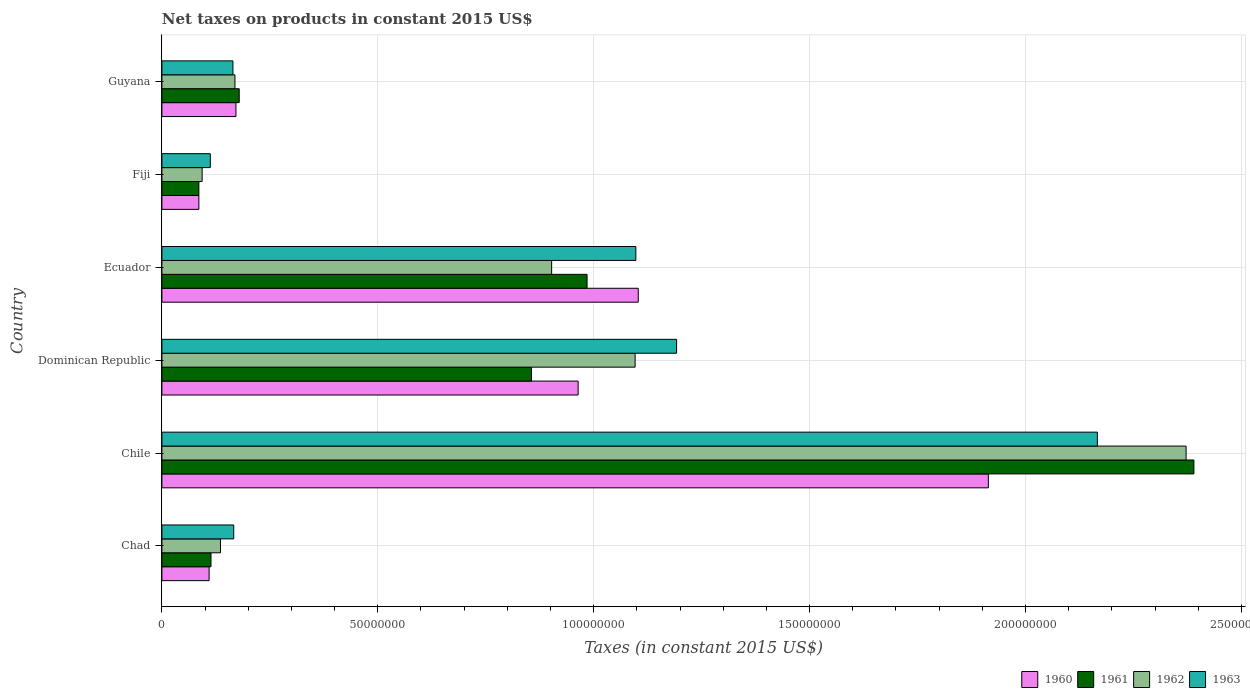How many different coloured bars are there?
Make the answer very short. 4. Are the number of bars per tick equal to the number of legend labels?
Provide a short and direct response. Yes. How many bars are there on the 5th tick from the top?
Your answer should be compact. 4. How many bars are there on the 5th tick from the bottom?
Keep it short and to the point. 4. What is the label of the 4th group of bars from the top?
Your response must be concise. Dominican Republic. In how many cases, is the number of bars for a given country not equal to the number of legend labels?
Make the answer very short. 0. What is the net taxes on products in 1962 in Chad?
Offer a terse response. 1.36e+07. Across all countries, what is the maximum net taxes on products in 1963?
Offer a very short reply. 2.17e+08. Across all countries, what is the minimum net taxes on products in 1962?
Your response must be concise. 9.32e+06. In which country was the net taxes on products in 1960 maximum?
Provide a succinct answer. Chile. In which country was the net taxes on products in 1962 minimum?
Ensure brevity in your answer.  Fiji. What is the total net taxes on products in 1962 in the graph?
Keep it short and to the point. 4.77e+08. What is the difference between the net taxes on products in 1961 in Ecuador and that in Fiji?
Offer a terse response. 8.99e+07. What is the difference between the net taxes on products in 1962 in Dominican Republic and the net taxes on products in 1963 in Fiji?
Offer a terse response. 9.84e+07. What is the average net taxes on products in 1960 per country?
Ensure brevity in your answer.  7.25e+07. What is the difference between the net taxes on products in 1963 and net taxes on products in 1960 in Fiji?
Keep it short and to the point. 2.64e+06. In how many countries, is the net taxes on products in 1961 greater than 40000000 US$?
Keep it short and to the point. 3. What is the ratio of the net taxes on products in 1960 in Dominican Republic to that in Fiji?
Your answer should be compact. 11.26. Is the difference between the net taxes on products in 1963 in Chad and Guyana greater than the difference between the net taxes on products in 1960 in Chad and Guyana?
Provide a short and direct response. Yes. What is the difference between the highest and the second highest net taxes on products in 1961?
Ensure brevity in your answer.  1.41e+08. What is the difference between the highest and the lowest net taxes on products in 1962?
Your answer should be compact. 2.28e+08. Is the sum of the net taxes on products in 1962 in Chile and Ecuador greater than the maximum net taxes on products in 1963 across all countries?
Keep it short and to the point. Yes. Is it the case that in every country, the sum of the net taxes on products in 1961 and net taxes on products in 1960 is greater than the sum of net taxes on products in 1963 and net taxes on products in 1962?
Ensure brevity in your answer.  No. What does the 1st bar from the top in Chile represents?
Your answer should be very brief. 1963. What does the 4th bar from the bottom in Dominican Republic represents?
Ensure brevity in your answer.  1963. Is it the case that in every country, the sum of the net taxes on products in 1961 and net taxes on products in 1962 is greater than the net taxes on products in 1960?
Make the answer very short. Yes. How many bars are there?
Offer a terse response. 24. Are all the bars in the graph horizontal?
Your answer should be very brief. Yes. How many countries are there in the graph?
Give a very brief answer. 6. What is the difference between two consecutive major ticks on the X-axis?
Your answer should be very brief. 5.00e+07. Does the graph contain grids?
Keep it short and to the point. Yes. How many legend labels are there?
Ensure brevity in your answer.  4. How are the legend labels stacked?
Your answer should be very brief. Horizontal. What is the title of the graph?
Keep it short and to the point. Net taxes on products in constant 2015 US$. What is the label or title of the X-axis?
Your answer should be compact. Taxes (in constant 2015 US$). What is the Taxes (in constant 2015 US$) in 1960 in Chad?
Your answer should be compact. 1.09e+07. What is the Taxes (in constant 2015 US$) of 1961 in Chad?
Ensure brevity in your answer.  1.14e+07. What is the Taxes (in constant 2015 US$) of 1962 in Chad?
Your response must be concise. 1.36e+07. What is the Taxes (in constant 2015 US$) of 1963 in Chad?
Offer a terse response. 1.66e+07. What is the Taxes (in constant 2015 US$) in 1960 in Chile?
Your answer should be compact. 1.91e+08. What is the Taxes (in constant 2015 US$) in 1961 in Chile?
Offer a terse response. 2.39e+08. What is the Taxes (in constant 2015 US$) in 1962 in Chile?
Ensure brevity in your answer.  2.37e+08. What is the Taxes (in constant 2015 US$) in 1963 in Chile?
Provide a succinct answer. 2.17e+08. What is the Taxes (in constant 2015 US$) in 1960 in Dominican Republic?
Keep it short and to the point. 9.64e+07. What is the Taxes (in constant 2015 US$) of 1961 in Dominican Republic?
Offer a terse response. 8.56e+07. What is the Taxes (in constant 2015 US$) in 1962 in Dominican Republic?
Give a very brief answer. 1.10e+08. What is the Taxes (in constant 2015 US$) in 1963 in Dominican Republic?
Your answer should be compact. 1.19e+08. What is the Taxes (in constant 2015 US$) in 1960 in Ecuador?
Your answer should be compact. 1.10e+08. What is the Taxes (in constant 2015 US$) in 1961 in Ecuador?
Provide a succinct answer. 9.85e+07. What is the Taxes (in constant 2015 US$) of 1962 in Ecuador?
Ensure brevity in your answer.  9.03e+07. What is the Taxes (in constant 2015 US$) of 1963 in Ecuador?
Offer a terse response. 1.10e+08. What is the Taxes (in constant 2015 US$) of 1960 in Fiji?
Make the answer very short. 8.56e+06. What is the Taxes (in constant 2015 US$) of 1961 in Fiji?
Your answer should be very brief. 8.56e+06. What is the Taxes (in constant 2015 US$) in 1962 in Fiji?
Make the answer very short. 9.32e+06. What is the Taxes (in constant 2015 US$) of 1963 in Fiji?
Offer a very short reply. 1.12e+07. What is the Taxes (in constant 2015 US$) of 1960 in Guyana?
Give a very brief answer. 1.71e+07. What is the Taxes (in constant 2015 US$) in 1961 in Guyana?
Give a very brief answer. 1.79e+07. What is the Taxes (in constant 2015 US$) in 1962 in Guyana?
Offer a terse response. 1.69e+07. What is the Taxes (in constant 2015 US$) in 1963 in Guyana?
Make the answer very short. 1.64e+07. Across all countries, what is the maximum Taxes (in constant 2015 US$) of 1960?
Make the answer very short. 1.91e+08. Across all countries, what is the maximum Taxes (in constant 2015 US$) of 1961?
Your answer should be very brief. 2.39e+08. Across all countries, what is the maximum Taxes (in constant 2015 US$) of 1962?
Offer a very short reply. 2.37e+08. Across all countries, what is the maximum Taxes (in constant 2015 US$) of 1963?
Offer a very short reply. 2.17e+08. Across all countries, what is the minimum Taxes (in constant 2015 US$) of 1960?
Offer a terse response. 8.56e+06. Across all countries, what is the minimum Taxes (in constant 2015 US$) in 1961?
Your answer should be very brief. 8.56e+06. Across all countries, what is the minimum Taxes (in constant 2015 US$) in 1962?
Your response must be concise. 9.32e+06. Across all countries, what is the minimum Taxes (in constant 2015 US$) in 1963?
Provide a short and direct response. 1.12e+07. What is the total Taxes (in constant 2015 US$) of 1960 in the graph?
Keep it short and to the point. 4.35e+08. What is the total Taxes (in constant 2015 US$) of 1961 in the graph?
Make the answer very short. 4.61e+08. What is the total Taxes (in constant 2015 US$) in 1962 in the graph?
Give a very brief answer. 4.77e+08. What is the total Taxes (in constant 2015 US$) in 1963 in the graph?
Offer a terse response. 4.90e+08. What is the difference between the Taxes (in constant 2015 US$) of 1960 in Chad and that in Chile?
Ensure brevity in your answer.  -1.80e+08. What is the difference between the Taxes (in constant 2015 US$) of 1961 in Chad and that in Chile?
Offer a very short reply. -2.28e+08. What is the difference between the Taxes (in constant 2015 US$) in 1962 in Chad and that in Chile?
Make the answer very short. -2.24e+08. What is the difference between the Taxes (in constant 2015 US$) in 1963 in Chad and that in Chile?
Give a very brief answer. -2.00e+08. What is the difference between the Taxes (in constant 2015 US$) in 1960 in Chad and that in Dominican Republic?
Ensure brevity in your answer.  -8.55e+07. What is the difference between the Taxes (in constant 2015 US$) of 1961 in Chad and that in Dominican Republic?
Provide a succinct answer. -7.42e+07. What is the difference between the Taxes (in constant 2015 US$) of 1962 in Chad and that in Dominican Republic?
Keep it short and to the point. -9.60e+07. What is the difference between the Taxes (in constant 2015 US$) of 1963 in Chad and that in Dominican Republic?
Your answer should be very brief. -1.03e+08. What is the difference between the Taxes (in constant 2015 US$) of 1960 in Chad and that in Ecuador?
Provide a short and direct response. -9.94e+07. What is the difference between the Taxes (in constant 2015 US$) in 1961 in Chad and that in Ecuador?
Give a very brief answer. -8.71e+07. What is the difference between the Taxes (in constant 2015 US$) in 1962 in Chad and that in Ecuador?
Ensure brevity in your answer.  -7.67e+07. What is the difference between the Taxes (in constant 2015 US$) in 1963 in Chad and that in Ecuador?
Provide a succinct answer. -9.31e+07. What is the difference between the Taxes (in constant 2015 US$) of 1960 in Chad and that in Fiji?
Give a very brief answer. 2.37e+06. What is the difference between the Taxes (in constant 2015 US$) in 1961 in Chad and that in Fiji?
Offer a terse response. 2.81e+06. What is the difference between the Taxes (in constant 2015 US$) in 1962 in Chad and that in Fiji?
Provide a short and direct response. 4.25e+06. What is the difference between the Taxes (in constant 2015 US$) in 1963 in Chad and that in Fiji?
Offer a very short reply. 5.43e+06. What is the difference between the Taxes (in constant 2015 US$) of 1960 in Chad and that in Guyana?
Your response must be concise. -6.21e+06. What is the difference between the Taxes (in constant 2015 US$) of 1961 in Chad and that in Guyana?
Keep it short and to the point. -6.54e+06. What is the difference between the Taxes (in constant 2015 US$) of 1962 in Chad and that in Guyana?
Provide a short and direct response. -3.35e+06. What is the difference between the Taxes (in constant 2015 US$) in 1963 in Chad and that in Guyana?
Give a very brief answer. 1.84e+05. What is the difference between the Taxes (in constant 2015 US$) of 1960 in Chile and that in Dominican Republic?
Make the answer very short. 9.50e+07. What is the difference between the Taxes (in constant 2015 US$) of 1961 in Chile and that in Dominican Republic?
Your answer should be compact. 1.53e+08. What is the difference between the Taxes (in constant 2015 US$) of 1962 in Chile and that in Dominican Republic?
Keep it short and to the point. 1.28e+08. What is the difference between the Taxes (in constant 2015 US$) of 1963 in Chile and that in Dominican Republic?
Provide a short and direct response. 9.74e+07. What is the difference between the Taxes (in constant 2015 US$) in 1960 in Chile and that in Ecuador?
Your answer should be very brief. 8.11e+07. What is the difference between the Taxes (in constant 2015 US$) in 1961 in Chile and that in Ecuador?
Ensure brevity in your answer.  1.41e+08. What is the difference between the Taxes (in constant 2015 US$) in 1962 in Chile and that in Ecuador?
Offer a very short reply. 1.47e+08. What is the difference between the Taxes (in constant 2015 US$) in 1963 in Chile and that in Ecuador?
Offer a terse response. 1.07e+08. What is the difference between the Taxes (in constant 2015 US$) in 1960 in Chile and that in Fiji?
Provide a succinct answer. 1.83e+08. What is the difference between the Taxes (in constant 2015 US$) in 1961 in Chile and that in Fiji?
Provide a short and direct response. 2.30e+08. What is the difference between the Taxes (in constant 2015 US$) of 1962 in Chile and that in Fiji?
Make the answer very short. 2.28e+08. What is the difference between the Taxes (in constant 2015 US$) in 1963 in Chile and that in Fiji?
Your answer should be very brief. 2.05e+08. What is the difference between the Taxes (in constant 2015 US$) of 1960 in Chile and that in Guyana?
Ensure brevity in your answer.  1.74e+08. What is the difference between the Taxes (in constant 2015 US$) in 1961 in Chile and that in Guyana?
Offer a very short reply. 2.21e+08. What is the difference between the Taxes (in constant 2015 US$) in 1962 in Chile and that in Guyana?
Provide a short and direct response. 2.20e+08. What is the difference between the Taxes (in constant 2015 US$) of 1963 in Chile and that in Guyana?
Your answer should be compact. 2.00e+08. What is the difference between the Taxes (in constant 2015 US$) in 1960 in Dominican Republic and that in Ecuador?
Make the answer very short. -1.39e+07. What is the difference between the Taxes (in constant 2015 US$) in 1961 in Dominican Republic and that in Ecuador?
Your answer should be compact. -1.29e+07. What is the difference between the Taxes (in constant 2015 US$) of 1962 in Dominican Republic and that in Ecuador?
Offer a very short reply. 1.93e+07. What is the difference between the Taxes (in constant 2015 US$) of 1963 in Dominican Republic and that in Ecuador?
Make the answer very short. 9.44e+06. What is the difference between the Taxes (in constant 2015 US$) of 1960 in Dominican Republic and that in Fiji?
Offer a terse response. 8.78e+07. What is the difference between the Taxes (in constant 2015 US$) in 1961 in Dominican Republic and that in Fiji?
Ensure brevity in your answer.  7.70e+07. What is the difference between the Taxes (in constant 2015 US$) in 1962 in Dominican Republic and that in Fiji?
Your answer should be very brief. 1.00e+08. What is the difference between the Taxes (in constant 2015 US$) in 1963 in Dominican Republic and that in Fiji?
Provide a succinct answer. 1.08e+08. What is the difference between the Taxes (in constant 2015 US$) in 1960 in Dominican Republic and that in Guyana?
Provide a short and direct response. 7.93e+07. What is the difference between the Taxes (in constant 2015 US$) of 1961 in Dominican Republic and that in Guyana?
Your answer should be very brief. 6.77e+07. What is the difference between the Taxes (in constant 2015 US$) of 1962 in Dominican Republic and that in Guyana?
Provide a succinct answer. 9.27e+07. What is the difference between the Taxes (in constant 2015 US$) in 1963 in Dominican Republic and that in Guyana?
Your answer should be very brief. 1.03e+08. What is the difference between the Taxes (in constant 2015 US$) of 1960 in Ecuador and that in Fiji?
Provide a succinct answer. 1.02e+08. What is the difference between the Taxes (in constant 2015 US$) of 1961 in Ecuador and that in Fiji?
Ensure brevity in your answer.  8.99e+07. What is the difference between the Taxes (in constant 2015 US$) in 1962 in Ecuador and that in Fiji?
Your response must be concise. 8.09e+07. What is the difference between the Taxes (in constant 2015 US$) in 1963 in Ecuador and that in Fiji?
Your answer should be compact. 9.86e+07. What is the difference between the Taxes (in constant 2015 US$) in 1960 in Ecuador and that in Guyana?
Make the answer very short. 9.32e+07. What is the difference between the Taxes (in constant 2015 US$) of 1961 in Ecuador and that in Guyana?
Make the answer very short. 8.06e+07. What is the difference between the Taxes (in constant 2015 US$) in 1962 in Ecuador and that in Guyana?
Give a very brief answer. 7.33e+07. What is the difference between the Taxes (in constant 2015 US$) in 1963 in Ecuador and that in Guyana?
Your answer should be very brief. 9.33e+07. What is the difference between the Taxes (in constant 2015 US$) of 1960 in Fiji and that in Guyana?
Provide a short and direct response. -8.59e+06. What is the difference between the Taxes (in constant 2015 US$) in 1961 in Fiji and that in Guyana?
Give a very brief answer. -9.34e+06. What is the difference between the Taxes (in constant 2015 US$) in 1962 in Fiji and that in Guyana?
Give a very brief answer. -7.60e+06. What is the difference between the Taxes (in constant 2015 US$) of 1963 in Fiji and that in Guyana?
Your response must be concise. -5.24e+06. What is the difference between the Taxes (in constant 2015 US$) in 1960 in Chad and the Taxes (in constant 2015 US$) in 1961 in Chile?
Provide a short and direct response. -2.28e+08. What is the difference between the Taxes (in constant 2015 US$) of 1960 in Chad and the Taxes (in constant 2015 US$) of 1962 in Chile?
Your response must be concise. -2.26e+08. What is the difference between the Taxes (in constant 2015 US$) in 1960 in Chad and the Taxes (in constant 2015 US$) in 1963 in Chile?
Ensure brevity in your answer.  -2.06e+08. What is the difference between the Taxes (in constant 2015 US$) of 1961 in Chad and the Taxes (in constant 2015 US$) of 1962 in Chile?
Provide a short and direct response. -2.26e+08. What is the difference between the Taxes (in constant 2015 US$) of 1961 in Chad and the Taxes (in constant 2015 US$) of 1963 in Chile?
Keep it short and to the point. -2.05e+08. What is the difference between the Taxes (in constant 2015 US$) in 1962 in Chad and the Taxes (in constant 2015 US$) in 1963 in Chile?
Offer a terse response. -2.03e+08. What is the difference between the Taxes (in constant 2015 US$) in 1960 in Chad and the Taxes (in constant 2015 US$) in 1961 in Dominican Republic?
Give a very brief answer. -7.47e+07. What is the difference between the Taxes (in constant 2015 US$) in 1960 in Chad and the Taxes (in constant 2015 US$) in 1962 in Dominican Republic?
Your answer should be compact. -9.87e+07. What is the difference between the Taxes (in constant 2015 US$) in 1960 in Chad and the Taxes (in constant 2015 US$) in 1963 in Dominican Republic?
Ensure brevity in your answer.  -1.08e+08. What is the difference between the Taxes (in constant 2015 US$) in 1961 in Chad and the Taxes (in constant 2015 US$) in 1962 in Dominican Republic?
Your response must be concise. -9.82e+07. What is the difference between the Taxes (in constant 2015 US$) of 1961 in Chad and the Taxes (in constant 2015 US$) of 1963 in Dominican Republic?
Give a very brief answer. -1.08e+08. What is the difference between the Taxes (in constant 2015 US$) in 1962 in Chad and the Taxes (in constant 2015 US$) in 1963 in Dominican Republic?
Your answer should be compact. -1.06e+08. What is the difference between the Taxes (in constant 2015 US$) of 1960 in Chad and the Taxes (in constant 2015 US$) of 1961 in Ecuador?
Your response must be concise. -8.75e+07. What is the difference between the Taxes (in constant 2015 US$) in 1960 in Chad and the Taxes (in constant 2015 US$) in 1962 in Ecuador?
Offer a terse response. -7.93e+07. What is the difference between the Taxes (in constant 2015 US$) of 1960 in Chad and the Taxes (in constant 2015 US$) of 1963 in Ecuador?
Your answer should be compact. -9.88e+07. What is the difference between the Taxes (in constant 2015 US$) in 1961 in Chad and the Taxes (in constant 2015 US$) in 1962 in Ecuador?
Make the answer very short. -7.89e+07. What is the difference between the Taxes (in constant 2015 US$) in 1961 in Chad and the Taxes (in constant 2015 US$) in 1963 in Ecuador?
Give a very brief answer. -9.84e+07. What is the difference between the Taxes (in constant 2015 US$) in 1962 in Chad and the Taxes (in constant 2015 US$) in 1963 in Ecuador?
Offer a very short reply. -9.62e+07. What is the difference between the Taxes (in constant 2015 US$) in 1960 in Chad and the Taxes (in constant 2015 US$) in 1961 in Fiji?
Keep it short and to the point. 2.37e+06. What is the difference between the Taxes (in constant 2015 US$) of 1960 in Chad and the Taxes (in constant 2015 US$) of 1962 in Fiji?
Offer a terse response. 1.62e+06. What is the difference between the Taxes (in constant 2015 US$) in 1960 in Chad and the Taxes (in constant 2015 US$) in 1963 in Fiji?
Provide a short and direct response. -2.73e+05. What is the difference between the Taxes (in constant 2015 US$) of 1961 in Chad and the Taxes (in constant 2015 US$) of 1962 in Fiji?
Make the answer very short. 2.05e+06. What is the difference between the Taxes (in constant 2015 US$) in 1961 in Chad and the Taxes (in constant 2015 US$) in 1963 in Fiji?
Your answer should be compact. 1.61e+05. What is the difference between the Taxes (in constant 2015 US$) in 1962 in Chad and the Taxes (in constant 2015 US$) in 1963 in Fiji?
Ensure brevity in your answer.  2.36e+06. What is the difference between the Taxes (in constant 2015 US$) of 1960 in Chad and the Taxes (in constant 2015 US$) of 1961 in Guyana?
Offer a very short reply. -6.97e+06. What is the difference between the Taxes (in constant 2015 US$) of 1960 in Chad and the Taxes (in constant 2015 US$) of 1962 in Guyana?
Give a very brief answer. -5.98e+06. What is the difference between the Taxes (in constant 2015 US$) of 1960 in Chad and the Taxes (in constant 2015 US$) of 1963 in Guyana?
Your response must be concise. -5.51e+06. What is the difference between the Taxes (in constant 2015 US$) in 1961 in Chad and the Taxes (in constant 2015 US$) in 1962 in Guyana?
Offer a very short reply. -5.55e+06. What is the difference between the Taxes (in constant 2015 US$) in 1961 in Chad and the Taxes (in constant 2015 US$) in 1963 in Guyana?
Your response must be concise. -5.08e+06. What is the difference between the Taxes (in constant 2015 US$) in 1962 in Chad and the Taxes (in constant 2015 US$) in 1963 in Guyana?
Keep it short and to the point. -2.88e+06. What is the difference between the Taxes (in constant 2015 US$) in 1960 in Chile and the Taxes (in constant 2015 US$) in 1961 in Dominican Republic?
Your answer should be very brief. 1.06e+08. What is the difference between the Taxes (in constant 2015 US$) of 1960 in Chile and the Taxes (in constant 2015 US$) of 1962 in Dominican Republic?
Ensure brevity in your answer.  8.18e+07. What is the difference between the Taxes (in constant 2015 US$) of 1960 in Chile and the Taxes (in constant 2015 US$) of 1963 in Dominican Republic?
Keep it short and to the point. 7.22e+07. What is the difference between the Taxes (in constant 2015 US$) in 1961 in Chile and the Taxes (in constant 2015 US$) in 1962 in Dominican Republic?
Ensure brevity in your answer.  1.29e+08. What is the difference between the Taxes (in constant 2015 US$) in 1961 in Chile and the Taxes (in constant 2015 US$) in 1963 in Dominican Republic?
Give a very brief answer. 1.20e+08. What is the difference between the Taxes (in constant 2015 US$) in 1962 in Chile and the Taxes (in constant 2015 US$) in 1963 in Dominican Republic?
Your response must be concise. 1.18e+08. What is the difference between the Taxes (in constant 2015 US$) in 1960 in Chile and the Taxes (in constant 2015 US$) in 1961 in Ecuador?
Your response must be concise. 9.29e+07. What is the difference between the Taxes (in constant 2015 US$) of 1960 in Chile and the Taxes (in constant 2015 US$) of 1962 in Ecuador?
Provide a short and direct response. 1.01e+08. What is the difference between the Taxes (in constant 2015 US$) of 1960 in Chile and the Taxes (in constant 2015 US$) of 1963 in Ecuador?
Ensure brevity in your answer.  8.16e+07. What is the difference between the Taxes (in constant 2015 US$) in 1961 in Chile and the Taxes (in constant 2015 US$) in 1962 in Ecuador?
Ensure brevity in your answer.  1.49e+08. What is the difference between the Taxes (in constant 2015 US$) of 1961 in Chile and the Taxes (in constant 2015 US$) of 1963 in Ecuador?
Ensure brevity in your answer.  1.29e+08. What is the difference between the Taxes (in constant 2015 US$) in 1962 in Chile and the Taxes (in constant 2015 US$) in 1963 in Ecuador?
Your answer should be very brief. 1.27e+08. What is the difference between the Taxes (in constant 2015 US$) of 1960 in Chile and the Taxes (in constant 2015 US$) of 1961 in Fiji?
Your answer should be very brief. 1.83e+08. What is the difference between the Taxes (in constant 2015 US$) in 1960 in Chile and the Taxes (in constant 2015 US$) in 1962 in Fiji?
Give a very brief answer. 1.82e+08. What is the difference between the Taxes (in constant 2015 US$) in 1960 in Chile and the Taxes (in constant 2015 US$) in 1963 in Fiji?
Keep it short and to the point. 1.80e+08. What is the difference between the Taxes (in constant 2015 US$) of 1961 in Chile and the Taxes (in constant 2015 US$) of 1962 in Fiji?
Offer a very short reply. 2.30e+08. What is the difference between the Taxes (in constant 2015 US$) in 1961 in Chile and the Taxes (in constant 2015 US$) in 1963 in Fiji?
Give a very brief answer. 2.28e+08. What is the difference between the Taxes (in constant 2015 US$) in 1962 in Chile and the Taxes (in constant 2015 US$) in 1963 in Fiji?
Offer a terse response. 2.26e+08. What is the difference between the Taxes (in constant 2015 US$) in 1960 in Chile and the Taxes (in constant 2015 US$) in 1961 in Guyana?
Offer a terse response. 1.73e+08. What is the difference between the Taxes (in constant 2015 US$) of 1960 in Chile and the Taxes (in constant 2015 US$) of 1962 in Guyana?
Ensure brevity in your answer.  1.74e+08. What is the difference between the Taxes (in constant 2015 US$) in 1960 in Chile and the Taxes (in constant 2015 US$) in 1963 in Guyana?
Your response must be concise. 1.75e+08. What is the difference between the Taxes (in constant 2015 US$) of 1961 in Chile and the Taxes (in constant 2015 US$) of 1962 in Guyana?
Give a very brief answer. 2.22e+08. What is the difference between the Taxes (in constant 2015 US$) of 1961 in Chile and the Taxes (in constant 2015 US$) of 1963 in Guyana?
Ensure brevity in your answer.  2.23e+08. What is the difference between the Taxes (in constant 2015 US$) in 1962 in Chile and the Taxes (in constant 2015 US$) in 1963 in Guyana?
Ensure brevity in your answer.  2.21e+08. What is the difference between the Taxes (in constant 2015 US$) in 1960 in Dominican Republic and the Taxes (in constant 2015 US$) in 1961 in Ecuador?
Your response must be concise. -2.07e+06. What is the difference between the Taxes (in constant 2015 US$) of 1960 in Dominican Republic and the Taxes (in constant 2015 US$) of 1962 in Ecuador?
Offer a very short reply. 6.14e+06. What is the difference between the Taxes (in constant 2015 US$) in 1960 in Dominican Republic and the Taxes (in constant 2015 US$) in 1963 in Ecuador?
Give a very brief answer. -1.34e+07. What is the difference between the Taxes (in constant 2015 US$) of 1961 in Dominican Republic and the Taxes (in constant 2015 US$) of 1962 in Ecuador?
Your answer should be very brief. -4.66e+06. What is the difference between the Taxes (in constant 2015 US$) in 1961 in Dominican Republic and the Taxes (in constant 2015 US$) in 1963 in Ecuador?
Your answer should be very brief. -2.42e+07. What is the difference between the Taxes (in constant 2015 US$) of 1962 in Dominican Republic and the Taxes (in constant 2015 US$) of 1963 in Ecuador?
Your answer should be very brief. -1.64e+05. What is the difference between the Taxes (in constant 2015 US$) in 1960 in Dominican Republic and the Taxes (in constant 2015 US$) in 1961 in Fiji?
Offer a terse response. 8.78e+07. What is the difference between the Taxes (in constant 2015 US$) in 1960 in Dominican Republic and the Taxes (in constant 2015 US$) in 1962 in Fiji?
Keep it short and to the point. 8.71e+07. What is the difference between the Taxes (in constant 2015 US$) of 1960 in Dominican Republic and the Taxes (in constant 2015 US$) of 1963 in Fiji?
Offer a very short reply. 8.52e+07. What is the difference between the Taxes (in constant 2015 US$) of 1961 in Dominican Republic and the Taxes (in constant 2015 US$) of 1962 in Fiji?
Provide a short and direct response. 7.63e+07. What is the difference between the Taxes (in constant 2015 US$) of 1961 in Dominican Republic and the Taxes (in constant 2015 US$) of 1963 in Fiji?
Provide a short and direct response. 7.44e+07. What is the difference between the Taxes (in constant 2015 US$) in 1962 in Dominican Republic and the Taxes (in constant 2015 US$) in 1963 in Fiji?
Make the answer very short. 9.84e+07. What is the difference between the Taxes (in constant 2015 US$) in 1960 in Dominican Republic and the Taxes (in constant 2015 US$) in 1961 in Guyana?
Make the answer very short. 7.85e+07. What is the difference between the Taxes (in constant 2015 US$) of 1960 in Dominican Republic and the Taxes (in constant 2015 US$) of 1962 in Guyana?
Provide a short and direct response. 7.95e+07. What is the difference between the Taxes (in constant 2015 US$) in 1960 in Dominican Republic and the Taxes (in constant 2015 US$) in 1963 in Guyana?
Provide a short and direct response. 8.00e+07. What is the difference between the Taxes (in constant 2015 US$) in 1961 in Dominican Republic and the Taxes (in constant 2015 US$) in 1962 in Guyana?
Provide a succinct answer. 6.87e+07. What is the difference between the Taxes (in constant 2015 US$) in 1961 in Dominican Republic and the Taxes (in constant 2015 US$) in 1963 in Guyana?
Offer a very short reply. 6.92e+07. What is the difference between the Taxes (in constant 2015 US$) of 1962 in Dominican Republic and the Taxes (in constant 2015 US$) of 1963 in Guyana?
Give a very brief answer. 9.32e+07. What is the difference between the Taxes (in constant 2015 US$) of 1960 in Ecuador and the Taxes (in constant 2015 US$) of 1961 in Fiji?
Offer a very short reply. 1.02e+08. What is the difference between the Taxes (in constant 2015 US$) of 1960 in Ecuador and the Taxes (in constant 2015 US$) of 1962 in Fiji?
Give a very brief answer. 1.01e+08. What is the difference between the Taxes (in constant 2015 US$) of 1960 in Ecuador and the Taxes (in constant 2015 US$) of 1963 in Fiji?
Your response must be concise. 9.91e+07. What is the difference between the Taxes (in constant 2015 US$) of 1961 in Ecuador and the Taxes (in constant 2015 US$) of 1962 in Fiji?
Your answer should be very brief. 8.91e+07. What is the difference between the Taxes (in constant 2015 US$) in 1961 in Ecuador and the Taxes (in constant 2015 US$) in 1963 in Fiji?
Provide a short and direct response. 8.73e+07. What is the difference between the Taxes (in constant 2015 US$) in 1962 in Ecuador and the Taxes (in constant 2015 US$) in 1963 in Fiji?
Ensure brevity in your answer.  7.91e+07. What is the difference between the Taxes (in constant 2015 US$) of 1960 in Ecuador and the Taxes (in constant 2015 US$) of 1961 in Guyana?
Your answer should be very brief. 9.24e+07. What is the difference between the Taxes (in constant 2015 US$) in 1960 in Ecuador and the Taxes (in constant 2015 US$) in 1962 in Guyana?
Your answer should be compact. 9.34e+07. What is the difference between the Taxes (in constant 2015 US$) in 1960 in Ecuador and the Taxes (in constant 2015 US$) in 1963 in Guyana?
Offer a very short reply. 9.39e+07. What is the difference between the Taxes (in constant 2015 US$) in 1961 in Ecuador and the Taxes (in constant 2015 US$) in 1962 in Guyana?
Keep it short and to the point. 8.16e+07. What is the difference between the Taxes (in constant 2015 US$) in 1961 in Ecuador and the Taxes (in constant 2015 US$) in 1963 in Guyana?
Your response must be concise. 8.20e+07. What is the difference between the Taxes (in constant 2015 US$) in 1962 in Ecuador and the Taxes (in constant 2015 US$) in 1963 in Guyana?
Keep it short and to the point. 7.38e+07. What is the difference between the Taxes (in constant 2015 US$) of 1960 in Fiji and the Taxes (in constant 2015 US$) of 1961 in Guyana?
Make the answer very short. -9.34e+06. What is the difference between the Taxes (in constant 2015 US$) in 1960 in Fiji and the Taxes (in constant 2015 US$) in 1962 in Guyana?
Make the answer very short. -8.35e+06. What is the difference between the Taxes (in constant 2015 US$) of 1960 in Fiji and the Taxes (in constant 2015 US$) of 1963 in Guyana?
Your response must be concise. -7.89e+06. What is the difference between the Taxes (in constant 2015 US$) in 1961 in Fiji and the Taxes (in constant 2015 US$) in 1962 in Guyana?
Your answer should be very brief. -8.35e+06. What is the difference between the Taxes (in constant 2015 US$) of 1961 in Fiji and the Taxes (in constant 2015 US$) of 1963 in Guyana?
Your response must be concise. -7.89e+06. What is the difference between the Taxes (in constant 2015 US$) of 1962 in Fiji and the Taxes (in constant 2015 US$) of 1963 in Guyana?
Provide a succinct answer. -7.13e+06. What is the average Taxes (in constant 2015 US$) of 1960 per country?
Keep it short and to the point. 7.25e+07. What is the average Taxes (in constant 2015 US$) in 1961 per country?
Give a very brief answer. 7.68e+07. What is the average Taxes (in constant 2015 US$) of 1962 per country?
Keep it short and to the point. 7.95e+07. What is the average Taxes (in constant 2015 US$) in 1963 per country?
Give a very brief answer. 8.17e+07. What is the difference between the Taxes (in constant 2015 US$) of 1960 and Taxes (in constant 2015 US$) of 1961 in Chad?
Provide a succinct answer. -4.34e+05. What is the difference between the Taxes (in constant 2015 US$) in 1960 and Taxes (in constant 2015 US$) in 1962 in Chad?
Offer a terse response. -2.63e+06. What is the difference between the Taxes (in constant 2015 US$) in 1960 and Taxes (in constant 2015 US$) in 1963 in Chad?
Your answer should be compact. -5.70e+06. What is the difference between the Taxes (in constant 2015 US$) of 1961 and Taxes (in constant 2015 US$) of 1962 in Chad?
Your answer should be very brief. -2.20e+06. What is the difference between the Taxes (in constant 2015 US$) of 1961 and Taxes (in constant 2015 US$) of 1963 in Chad?
Make the answer very short. -5.26e+06. What is the difference between the Taxes (in constant 2015 US$) of 1962 and Taxes (in constant 2015 US$) of 1963 in Chad?
Provide a succinct answer. -3.06e+06. What is the difference between the Taxes (in constant 2015 US$) of 1960 and Taxes (in constant 2015 US$) of 1961 in Chile?
Make the answer very short. -4.76e+07. What is the difference between the Taxes (in constant 2015 US$) in 1960 and Taxes (in constant 2015 US$) in 1962 in Chile?
Keep it short and to the point. -4.58e+07. What is the difference between the Taxes (in constant 2015 US$) of 1960 and Taxes (in constant 2015 US$) of 1963 in Chile?
Your answer should be compact. -2.52e+07. What is the difference between the Taxes (in constant 2015 US$) in 1961 and Taxes (in constant 2015 US$) in 1962 in Chile?
Provide a succinct answer. 1.81e+06. What is the difference between the Taxes (in constant 2015 US$) in 1961 and Taxes (in constant 2015 US$) in 1963 in Chile?
Offer a very short reply. 2.24e+07. What is the difference between the Taxes (in constant 2015 US$) in 1962 and Taxes (in constant 2015 US$) in 1963 in Chile?
Your answer should be very brief. 2.06e+07. What is the difference between the Taxes (in constant 2015 US$) of 1960 and Taxes (in constant 2015 US$) of 1961 in Dominican Republic?
Your answer should be compact. 1.08e+07. What is the difference between the Taxes (in constant 2015 US$) of 1960 and Taxes (in constant 2015 US$) of 1962 in Dominican Republic?
Your response must be concise. -1.32e+07. What is the difference between the Taxes (in constant 2015 US$) of 1960 and Taxes (in constant 2015 US$) of 1963 in Dominican Republic?
Offer a terse response. -2.28e+07. What is the difference between the Taxes (in constant 2015 US$) of 1961 and Taxes (in constant 2015 US$) of 1962 in Dominican Republic?
Make the answer very short. -2.40e+07. What is the difference between the Taxes (in constant 2015 US$) in 1961 and Taxes (in constant 2015 US$) in 1963 in Dominican Republic?
Offer a very short reply. -3.36e+07. What is the difference between the Taxes (in constant 2015 US$) in 1962 and Taxes (in constant 2015 US$) in 1963 in Dominican Republic?
Offer a terse response. -9.60e+06. What is the difference between the Taxes (in constant 2015 US$) in 1960 and Taxes (in constant 2015 US$) in 1961 in Ecuador?
Provide a short and direct response. 1.19e+07. What is the difference between the Taxes (in constant 2015 US$) in 1960 and Taxes (in constant 2015 US$) in 1962 in Ecuador?
Your response must be concise. 2.01e+07. What is the difference between the Taxes (in constant 2015 US$) of 1960 and Taxes (in constant 2015 US$) of 1963 in Ecuador?
Ensure brevity in your answer.  5.57e+05. What is the difference between the Taxes (in constant 2015 US$) in 1961 and Taxes (in constant 2015 US$) in 1962 in Ecuador?
Provide a short and direct response. 8.21e+06. What is the difference between the Taxes (in constant 2015 US$) in 1961 and Taxes (in constant 2015 US$) in 1963 in Ecuador?
Your answer should be compact. -1.13e+07. What is the difference between the Taxes (in constant 2015 US$) of 1962 and Taxes (in constant 2015 US$) of 1963 in Ecuador?
Your answer should be compact. -1.95e+07. What is the difference between the Taxes (in constant 2015 US$) of 1960 and Taxes (in constant 2015 US$) of 1962 in Fiji?
Your answer should be very brief. -7.56e+05. What is the difference between the Taxes (in constant 2015 US$) of 1960 and Taxes (in constant 2015 US$) of 1963 in Fiji?
Keep it short and to the point. -2.64e+06. What is the difference between the Taxes (in constant 2015 US$) of 1961 and Taxes (in constant 2015 US$) of 1962 in Fiji?
Keep it short and to the point. -7.56e+05. What is the difference between the Taxes (in constant 2015 US$) in 1961 and Taxes (in constant 2015 US$) in 1963 in Fiji?
Ensure brevity in your answer.  -2.64e+06. What is the difference between the Taxes (in constant 2015 US$) in 1962 and Taxes (in constant 2015 US$) in 1963 in Fiji?
Your answer should be very brief. -1.89e+06. What is the difference between the Taxes (in constant 2015 US$) of 1960 and Taxes (in constant 2015 US$) of 1961 in Guyana?
Your answer should be compact. -7.58e+05. What is the difference between the Taxes (in constant 2015 US$) in 1960 and Taxes (in constant 2015 US$) in 1962 in Guyana?
Give a very brief answer. 2.33e+05. What is the difference between the Taxes (in constant 2015 US$) of 1960 and Taxes (in constant 2015 US$) of 1963 in Guyana?
Keep it short and to the point. 7.00e+05. What is the difference between the Taxes (in constant 2015 US$) of 1961 and Taxes (in constant 2015 US$) of 1962 in Guyana?
Provide a succinct answer. 9.92e+05. What is the difference between the Taxes (in constant 2015 US$) of 1961 and Taxes (in constant 2015 US$) of 1963 in Guyana?
Keep it short and to the point. 1.46e+06. What is the difference between the Taxes (in constant 2015 US$) in 1962 and Taxes (in constant 2015 US$) in 1963 in Guyana?
Your response must be concise. 4.67e+05. What is the ratio of the Taxes (in constant 2015 US$) in 1960 in Chad to that in Chile?
Offer a very short reply. 0.06. What is the ratio of the Taxes (in constant 2015 US$) in 1961 in Chad to that in Chile?
Make the answer very short. 0.05. What is the ratio of the Taxes (in constant 2015 US$) in 1962 in Chad to that in Chile?
Provide a succinct answer. 0.06. What is the ratio of the Taxes (in constant 2015 US$) of 1963 in Chad to that in Chile?
Ensure brevity in your answer.  0.08. What is the ratio of the Taxes (in constant 2015 US$) in 1960 in Chad to that in Dominican Republic?
Provide a succinct answer. 0.11. What is the ratio of the Taxes (in constant 2015 US$) of 1961 in Chad to that in Dominican Republic?
Ensure brevity in your answer.  0.13. What is the ratio of the Taxes (in constant 2015 US$) in 1962 in Chad to that in Dominican Republic?
Offer a terse response. 0.12. What is the ratio of the Taxes (in constant 2015 US$) of 1963 in Chad to that in Dominican Republic?
Provide a short and direct response. 0.14. What is the ratio of the Taxes (in constant 2015 US$) of 1960 in Chad to that in Ecuador?
Provide a short and direct response. 0.1. What is the ratio of the Taxes (in constant 2015 US$) of 1961 in Chad to that in Ecuador?
Give a very brief answer. 0.12. What is the ratio of the Taxes (in constant 2015 US$) in 1962 in Chad to that in Ecuador?
Make the answer very short. 0.15. What is the ratio of the Taxes (in constant 2015 US$) in 1963 in Chad to that in Ecuador?
Your answer should be compact. 0.15. What is the ratio of the Taxes (in constant 2015 US$) of 1960 in Chad to that in Fiji?
Provide a short and direct response. 1.28. What is the ratio of the Taxes (in constant 2015 US$) of 1961 in Chad to that in Fiji?
Your response must be concise. 1.33. What is the ratio of the Taxes (in constant 2015 US$) of 1962 in Chad to that in Fiji?
Your response must be concise. 1.46. What is the ratio of the Taxes (in constant 2015 US$) in 1963 in Chad to that in Fiji?
Offer a very short reply. 1.48. What is the ratio of the Taxes (in constant 2015 US$) of 1960 in Chad to that in Guyana?
Your answer should be compact. 0.64. What is the ratio of the Taxes (in constant 2015 US$) in 1961 in Chad to that in Guyana?
Offer a very short reply. 0.63. What is the ratio of the Taxes (in constant 2015 US$) of 1962 in Chad to that in Guyana?
Give a very brief answer. 0.8. What is the ratio of the Taxes (in constant 2015 US$) of 1963 in Chad to that in Guyana?
Make the answer very short. 1.01. What is the ratio of the Taxes (in constant 2015 US$) in 1960 in Chile to that in Dominican Republic?
Your answer should be compact. 1.99. What is the ratio of the Taxes (in constant 2015 US$) in 1961 in Chile to that in Dominican Republic?
Your answer should be very brief. 2.79. What is the ratio of the Taxes (in constant 2015 US$) in 1962 in Chile to that in Dominican Republic?
Your answer should be very brief. 2.16. What is the ratio of the Taxes (in constant 2015 US$) in 1963 in Chile to that in Dominican Republic?
Make the answer very short. 1.82. What is the ratio of the Taxes (in constant 2015 US$) in 1960 in Chile to that in Ecuador?
Keep it short and to the point. 1.74. What is the ratio of the Taxes (in constant 2015 US$) of 1961 in Chile to that in Ecuador?
Keep it short and to the point. 2.43. What is the ratio of the Taxes (in constant 2015 US$) of 1962 in Chile to that in Ecuador?
Make the answer very short. 2.63. What is the ratio of the Taxes (in constant 2015 US$) of 1963 in Chile to that in Ecuador?
Provide a succinct answer. 1.97. What is the ratio of the Taxes (in constant 2015 US$) in 1960 in Chile to that in Fiji?
Make the answer very short. 22.35. What is the ratio of the Taxes (in constant 2015 US$) of 1961 in Chile to that in Fiji?
Make the answer very short. 27.91. What is the ratio of the Taxes (in constant 2015 US$) in 1962 in Chile to that in Fiji?
Offer a terse response. 25.45. What is the ratio of the Taxes (in constant 2015 US$) of 1963 in Chile to that in Fiji?
Give a very brief answer. 19.33. What is the ratio of the Taxes (in constant 2015 US$) of 1960 in Chile to that in Guyana?
Make the answer very short. 11.16. What is the ratio of the Taxes (in constant 2015 US$) of 1961 in Chile to that in Guyana?
Provide a succinct answer. 13.35. What is the ratio of the Taxes (in constant 2015 US$) of 1962 in Chile to that in Guyana?
Your response must be concise. 14.02. What is the ratio of the Taxes (in constant 2015 US$) of 1963 in Chile to that in Guyana?
Ensure brevity in your answer.  13.17. What is the ratio of the Taxes (in constant 2015 US$) of 1960 in Dominican Republic to that in Ecuador?
Your answer should be very brief. 0.87. What is the ratio of the Taxes (in constant 2015 US$) of 1961 in Dominican Republic to that in Ecuador?
Your response must be concise. 0.87. What is the ratio of the Taxes (in constant 2015 US$) in 1962 in Dominican Republic to that in Ecuador?
Offer a terse response. 1.21. What is the ratio of the Taxes (in constant 2015 US$) in 1963 in Dominican Republic to that in Ecuador?
Provide a short and direct response. 1.09. What is the ratio of the Taxes (in constant 2015 US$) of 1960 in Dominican Republic to that in Fiji?
Provide a succinct answer. 11.26. What is the ratio of the Taxes (in constant 2015 US$) in 1961 in Dominican Republic to that in Fiji?
Make the answer very short. 10. What is the ratio of the Taxes (in constant 2015 US$) of 1962 in Dominican Republic to that in Fiji?
Give a very brief answer. 11.76. What is the ratio of the Taxes (in constant 2015 US$) of 1963 in Dominican Republic to that in Fiji?
Provide a succinct answer. 10.63. What is the ratio of the Taxes (in constant 2015 US$) in 1960 in Dominican Republic to that in Guyana?
Offer a very short reply. 5.62. What is the ratio of the Taxes (in constant 2015 US$) in 1961 in Dominican Republic to that in Guyana?
Keep it short and to the point. 4.78. What is the ratio of the Taxes (in constant 2015 US$) in 1962 in Dominican Republic to that in Guyana?
Make the answer very short. 6.48. What is the ratio of the Taxes (in constant 2015 US$) in 1963 in Dominican Republic to that in Guyana?
Your answer should be very brief. 7.25. What is the ratio of the Taxes (in constant 2015 US$) in 1960 in Ecuador to that in Fiji?
Give a very brief answer. 12.88. What is the ratio of the Taxes (in constant 2015 US$) in 1961 in Ecuador to that in Fiji?
Offer a terse response. 11.5. What is the ratio of the Taxes (in constant 2015 US$) of 1962 in Ecuador to that in Fiji?
Offer a terse response. 9.69. What is the ratio of the Taxes (in constant 2015 US$) in 1963 in Ecuador to that in Fiji?
Your response must be concise. 9.79. What is the ratio of the Taxes (in constant 2015 US$) in 1960 in Ecuador to that in Guyana?
Provide a succinct answer. 6.43. What is the ratio of the Taxes (in constant 2015 US$) of 1961 in Ecuador to that in Guyana?
Ensure brevity in your answer.  5.5. What is the ratio of the Taxes (in constant 2015 US$) of 1962 in Ecuador to that in Guyana?
Provide a short and direct response. 5.34. What is the ratio of the Taxes (in constant 2015 US$) of 1963 in Ecuador to that in Guyana?
Your answer should be compact. 6.67. What is the ratio of the Taxes (in constant 2015 US$) of 1960 in Fiji to that in Guyana?
Make the answer very short. 0.5. What is the ratio of the Taxes (in constant 2015 US$) in 1961 in Fiji to that in Guyana?
Your answer should be compact. 0.48. What is the ratio of the Taxes (in constant 2015 US$) in 1962 in Fiji to that in Guyana?
Offer a terse response. 0.55. What is the ratio of the Taxes (in constant 2015 US$) of 1963 in Fiji to that in Guyana?
Make the answer very short. 0.68. What is the difference between the highest and the second highest Taxes (in constant 2015 US$) of 1960?
Provide a succinct answer. 8.11e+07. What is the difference between the highest and the second highest Taxes (in constant 2015 US$) of 1961?
Give a very brief answer. 1.41e+08. What is the difference between the highest and the second highest Taxes (in constant 2015 US$) in 1962?
Provide a short and direct response. 1.28e+08. What is the difference between the highest and the second highest Taxes (in constant 2015 US$) in 1963?
Make the answer very short. 9.74e+07. What is the difference between the highest and the lowest Taxes (in constant 2015 US$) of 1960?
Make the answer very short. 1.83e+08. What is the difference between the highest and the lowest Taxes (in constant 2015 US$) in 1961?
Provide a short and direct response. 2.30e+08. What is the difference between the highest and the lowest Taxes (in constant 2015 US$) in 1962?
Provide a succinct answer. 2.28e+08. What is the difference between the highest and the lowest Taxes (in constant 2015 US$) of 1963?
Your answer should be very brief. 2.05e+08. 